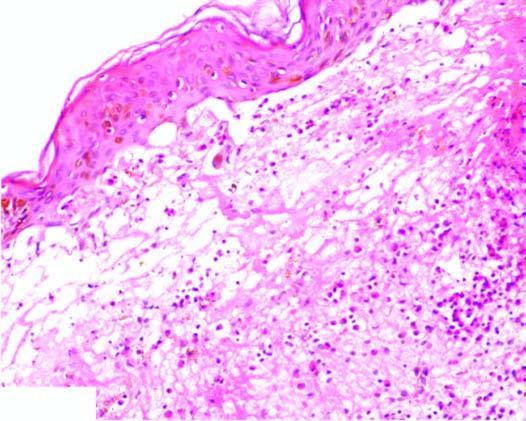what show neutrophilic microabscess causing dermo-epidermal separation at tips?
Answer the question using a single word or phrase. Tips of dermal papillae 